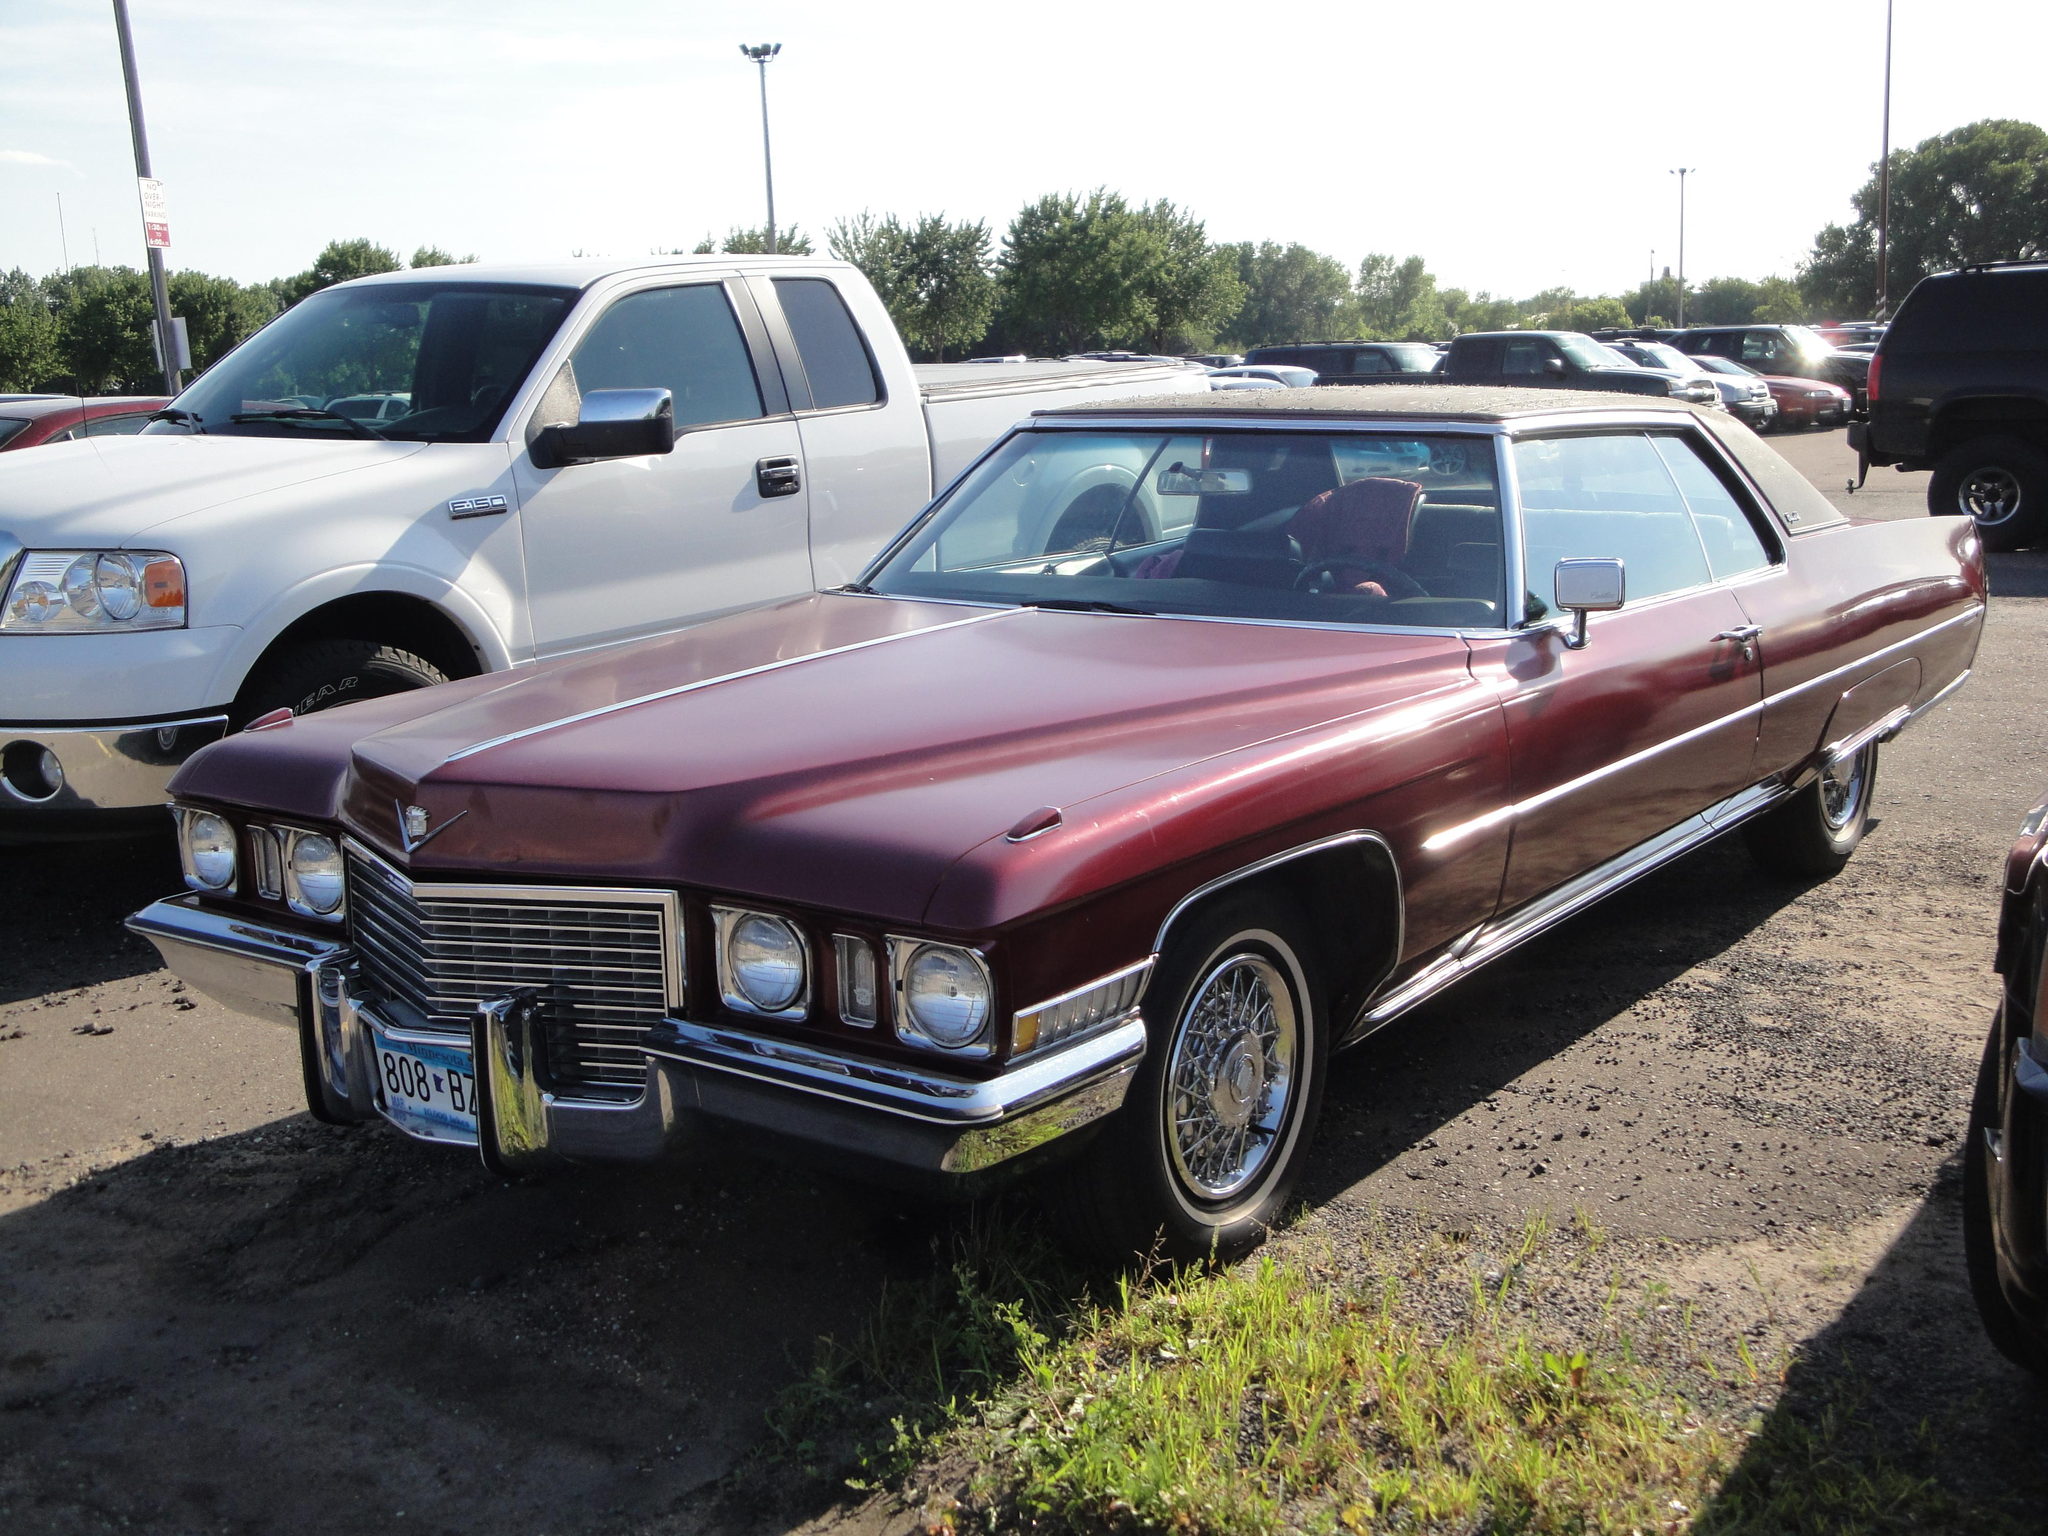What is the main subject of the image? The main subject of the image is a group of cars. How are the cars positioned in the image? The cars are placed on the ground. What type of natural elements can be seen in the image? There are stones, grass, and a group of trees in the image. What man-made structures are present in the image? There are poles and boards in the image. What is visible in the background of the image? The sky is visible in the image, and it appears to be cloudy. What type of coat is draped over the car in the image? There is no coat draped over any car in the image. What type of dirt can be seen on the tires of the cars in the image? There is no dirt visible on the tires of the cars in the image. 